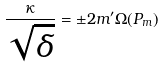<formula> <loc_0><loc_0><loc_500><loc_500>\frac { \kappa } { \sqrt { \delta } } = \pm 2 m ^ { \prime } \Omega ( P _ { m } )</formula> 